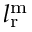Convert formula to latex. <formula><loc_0><loc_0><loc_500><loc_500>l _ { r } ^ { m }</formula> 